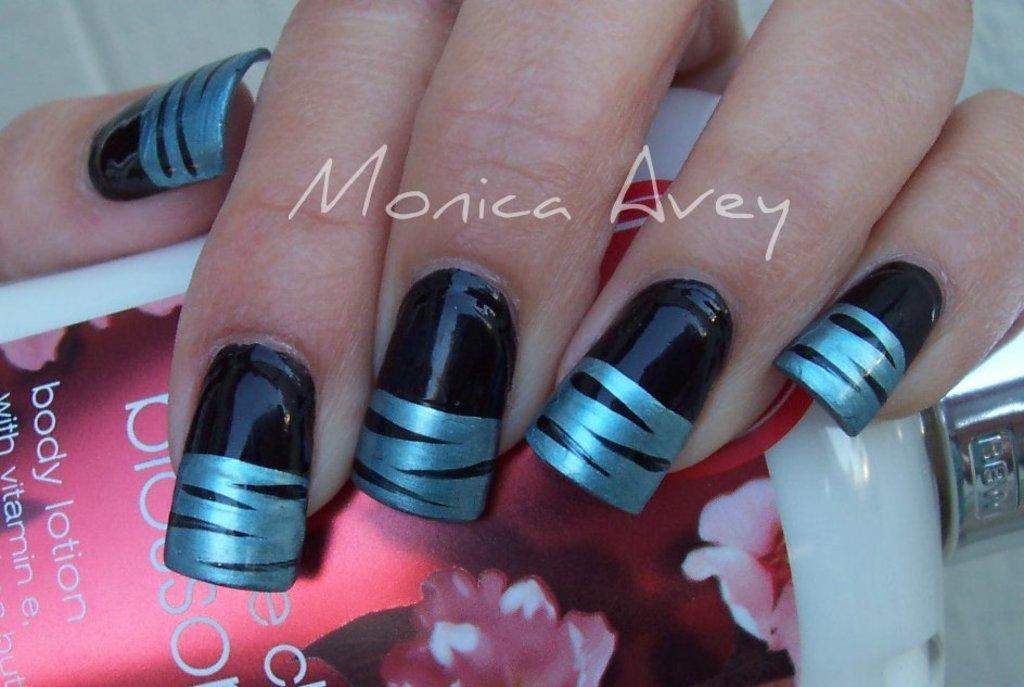Could you give a brief overview of what you see in this image? In this picture we can observe nails. There is a nail polish on the nails which is in black and silver color. We can observe a white color watermark on this picture. There is a pink color bottle. 